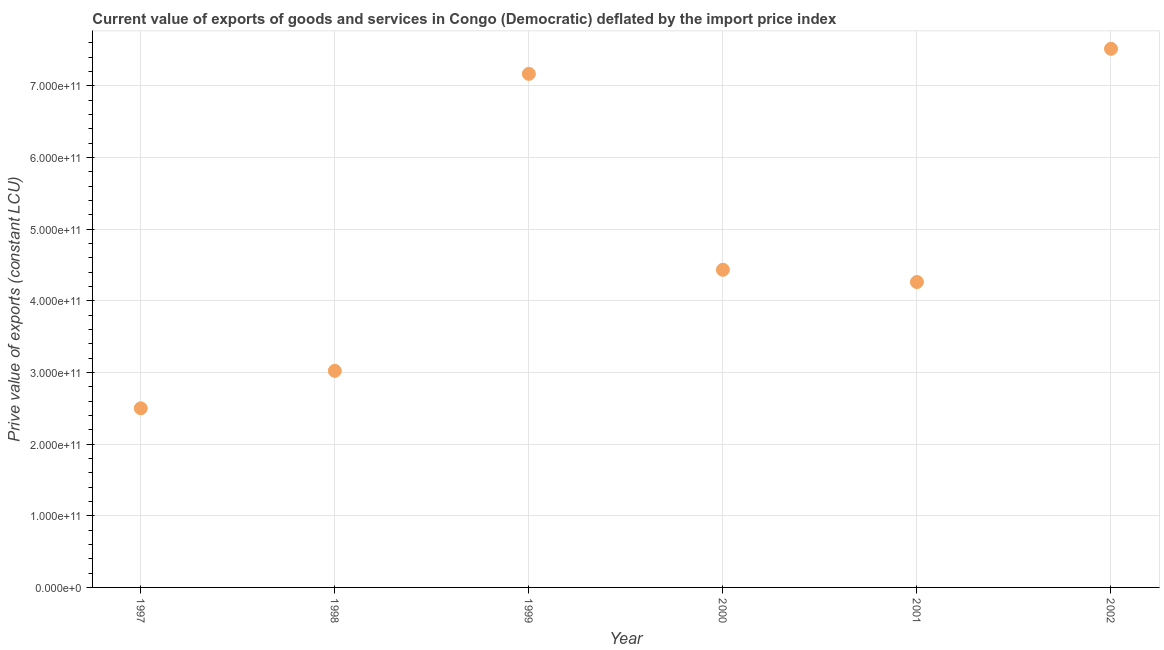What is the price value of exports in 1998?
Make the answer very short. 3.02e+11. Across all years, what is the maximum price value of exports?
Provide a short and direct response. 7.52e+11. Across all years, what is the minimum price value of exports?
Ensure brevity in your answer.  2.50e+11. In which year was the price value of exports maximum?
Ensure brevity in your answer.  2002. What is the sum of the price value of exports?
Ensure brevity in your answer.  2.89e+12. What is the difference between the price value of exports in 2001 and 2002?
Your answer should be compact. -3.26e+11. What is the average price value of exports per year?
Offer a terse response. 4.82e+11. What is the median price value of exports?
Your answer should be compact. 4.35e+11. In how many years, is the price value of exports greater than 160000000000 LCU?
Provide a succinct answer. 6. Do a majority of the years between 2001 and 1999 (inclusive) have price value of exports greater than 460000000000 LCU?
Your answer should be very brief. No. What is the ratio of the price value of exports in 1997 to that in 2002?
Provide a short and direct response. 0.33. Is the price value of exports in 1997 less than that in 2000?
Keep it short and to the point. Yes. Is the difference between the price value of exports in 1998 and 2001 greater than the difference between any two years?
Give a very brief answer. No. What is the difference between the highest and the second highest price value of exports?
Give a very brief answer. 3.50e+1. Is the sum of the price value of exports in 1998 and 1999 greater than the maximum price value of exports across all years?
Offer a very short reply. Yes. What is the difference between the highest and the lowest price value of exports?
Provide a short and direct response. 5.02e+11. Does the price value of exports monotonically increase over the years?
Give a very brief answer. No. How many dotlines are there?
Your answer should be compact. 1. What is the difference between two consecutive major ticks on the Y-axis?
Your answer should be compact. 1.00e+11. Are the values on the major ticks of Y-axis written in scientific E-notation?
Your response must be concise. Yes. What is the title of the graph?
Offer a terse response. Current value of exports of goods and services in Congo (Democratic) deflated by the import price index. What is the label or title of the X-axis?
Your answer should be very brief. Year. What is the label or title of the Y-axis?
Ensure brevity in your answer.  Prive value of exports (constant LCU). What is the Prive value of exports (constant LCU) in 1997?
Give a very brief answer. 2.50e+11. What is the Prive value of exports (constant LCU) in 1998?
Offer a very short reply. 3.02e+11. What is the Prive value of exports (constant LCU) in 1999?
Ensure brevity in your answer.  7.17e+11. What is the Prive value of exports (constant LCU) in 2000?
Provide a short and direct response. 4.43e+11. What is the Prive value of exports (constant LCU) in 2001?
Your response must be concise. 4.26e+11. What is the Prive value of exports (constant LCU) in 2002?
Keep it short and to the point. 7.52e+11. What is the difference between the Prive value of exports (constant LCU) in 1997 and 1998?
Ensure brevity in your answer.  -5.23e+1. What is the difference between the Prive value of exports (constant LCU) in 1997 and 1999?
Your answer should be very brief. -4.67e+11. What is the difference between the Prive value of exports (constant LCU) in 1997 and 2000?
Ensure brevity in your answer.  -1.93e+11. What is the difference between the Prive value of exports (constant LCU) in 1997 and 2001?
Give a very brief answer. -1.76e+11. What is the difference between the Prive value of exports (constant LCU) in 1997 and 2002?
Offer a terse response. -5.02e+11. What is the difference between the Prive value of exports (constant LCU) in 1998 and 1999?
Your answer should be compact. -4.15e+11. What is the difference between the Prive value of exports (constant LCU) in 1998 and 2000?
Keep it short and to the point. -1.41e+11. What is the difference between the Prive value of exports (constant LCU) in 1998 and 2001?
Give a very brief answer. -1.24e+11. What is the difference between the Prive value of exports (constant LCU) in 1998 and 2002?
Give a very brief answer. -4.50e+11. What is the difference between the Prive value of exports (constant LCU) in 1999 and 2000?
Your answer should be compact. 2.73e+11. What is the difference between the Prive value of exports (constant LCU) in 1999 and 2001?
Make the answer very short. 2.91e+11. What is the difference between the Prive value of exports (constant LCU) in 1999 and 2002?
Your answer should be compact. -3.50e+1. What is the difference between the Prive value of exports (constant LCU) in 2000 and 2001?
Your response must be concise. 1.71e+1. What is the difference between the Prive value of exports (constant LCU) in 2000 and 2002?
Provide a succinct answer. -3.08e+11. What is the difference between the Prive value of exports (constant LCU) in 2001 and 2002?
Your answer should be very brief. -3.26e+11. What is the ratio of the Prive value of exports (constant LCU) in 1997 to that in 1998?
Give a very brief answer. 0.83. What is the ratio of the Prive value of exports (constant LCU) in 1997 to that in 1999?
Keep it short and to the point. 0.35. What is the ratio of the Prive value of exports (constant LCU) in 1997 to that in 2000?
Your response must be concise. 0.56. What is the ratio of the Prive value of exports (constant LCU) in 1997 to that in 2001?
Provide a short and direct response. 0.59. What is the ratio of the Prive value of exports (constant LCU) in 1997 to that in 2002?
Provide a succinct answer. 0.33. What is the ratio of the Prive value of exports (constant LCU) in 1998 to that in 1999?
Your answer should be compact. 0.42. What is the ratio of the Prive value of exports (constant LCU) in 1998 to that in 2000?
Provide a succinct answer. 0.68. What is the ratio of the Prive value of exports (constant LCU) in 1998 to that in 2001?
Offer a very short reply. 0.71. What is the ratio of the Prive value of exports (constant LCU) in 1998 to that in 2002?
Give a very brief answer. 0.4. What is the ratio of the Prive value of exports (constant LCU) in 1999 to that in 2000?
Offer a very short reply. 1.62. What is the ratio of the Prive value of exports (constant LCU) in 1999 to that in 2001?
Ensure brevity in your answer.  1.68. What is the ratio of the Prive value of exports (constant LCU) in 1999 to that in 2002?
Give a very brief answer. 0.95. What is the ratio of the Prive value of exports (constant LCU) in 2000 to that in 2002?
Your response must be concise. 0.59. What is the ratio of the Prive value of exports (constant LCU) in 2001 to that in 2002?
Provide a short and direct response. 0.57. 